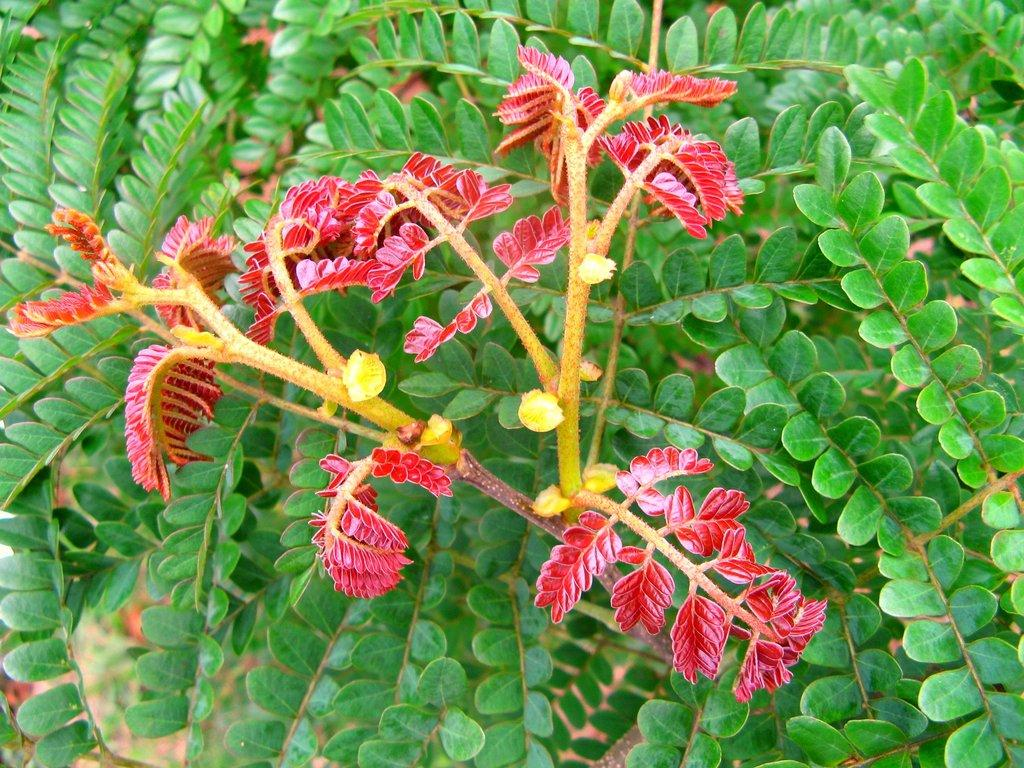What is the main subject of the image? The main subject of the image is a branch of a tree. What can be observed about the leaves on the branch? There are green leaves and red leaves on the branch. What type of trousers can be seen hanging on the branch in the image? There are no trousers present in the image; it features a branch with green and red leaves. 